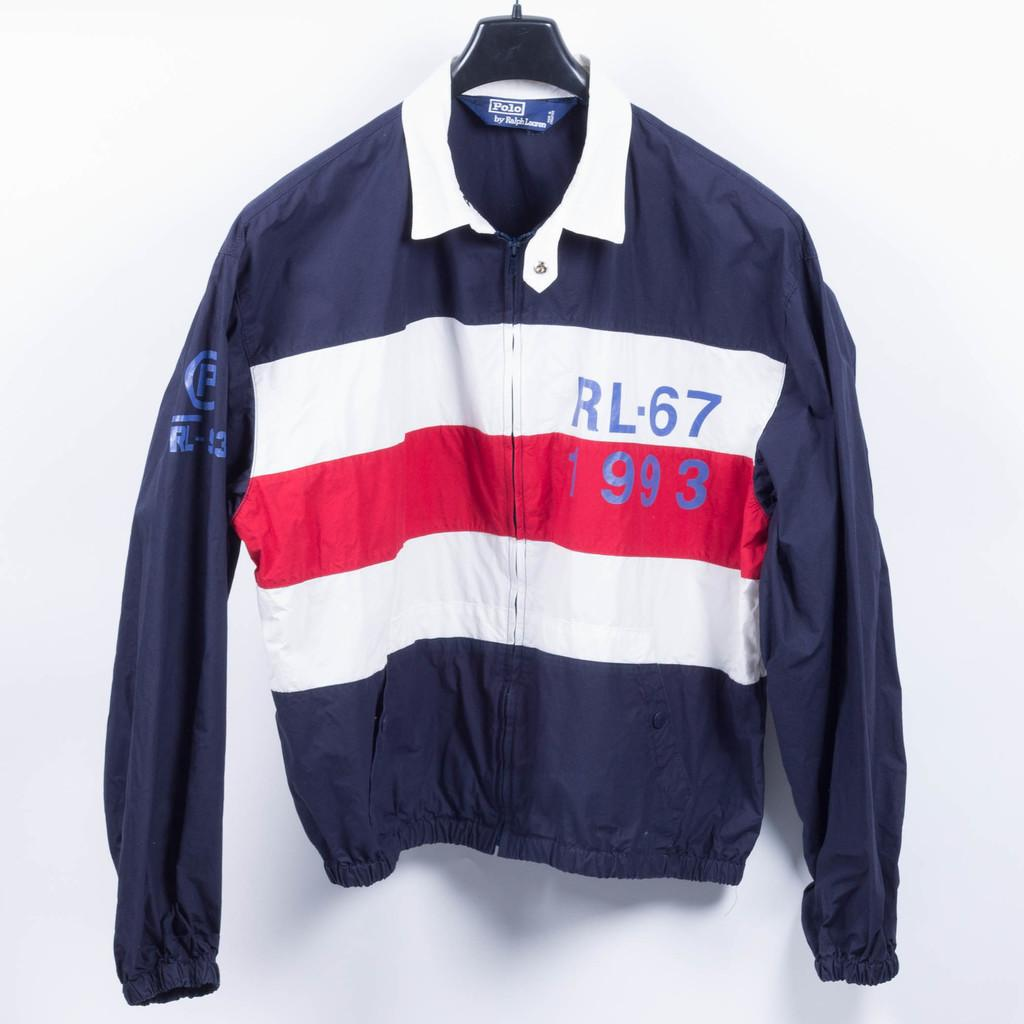Provide a one-sentence caption for the provided image. A blue Ralph Laruen jacket with 2 white striples and a red striple across the mid section. 